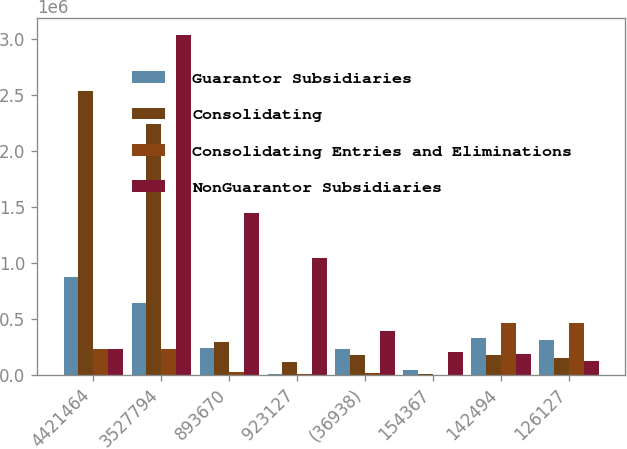Convert chart to OTSL. <chart><loc_0><loc_0><loc_500><loc_500><stacked_bar_chart><ecel><fcel>4421464<fcel>3527794<fcel>893670<fcel>923127<fcel>(36938)<fcel>154367<fcel>142494<fcel>126127<nl><fcel>Guarantor Subsidiaries<fcel>875358<fcel>640341<fcel>235017<fcel>4096<fcel>230849<fcel>42299<fcel>326121<fcel>312741<nl><fcel>Consolidating<fcel>2.53289e+06<fcel>2.2402e+06<fcel>292683<fcel>112332<fcel>176317<fcel>2544<fcel>173773<fcel>145521<nl><fcel>Consolidating Entries and Eliminations<fcel>230849<fcel>230849<fcel>19540<fcel>1199<fcel>18341<fcel>2<fcel>458262<fcel>458262<nl><fcel>NonGuarantor Subsidiaries<fcel>230849<fcel>3.03363e+06<fcel>1.44091e+06<fcel>1.04075e+06<fcel>388569<fcel>199208<fcel>184126<fcel>126127<nl></chart> 